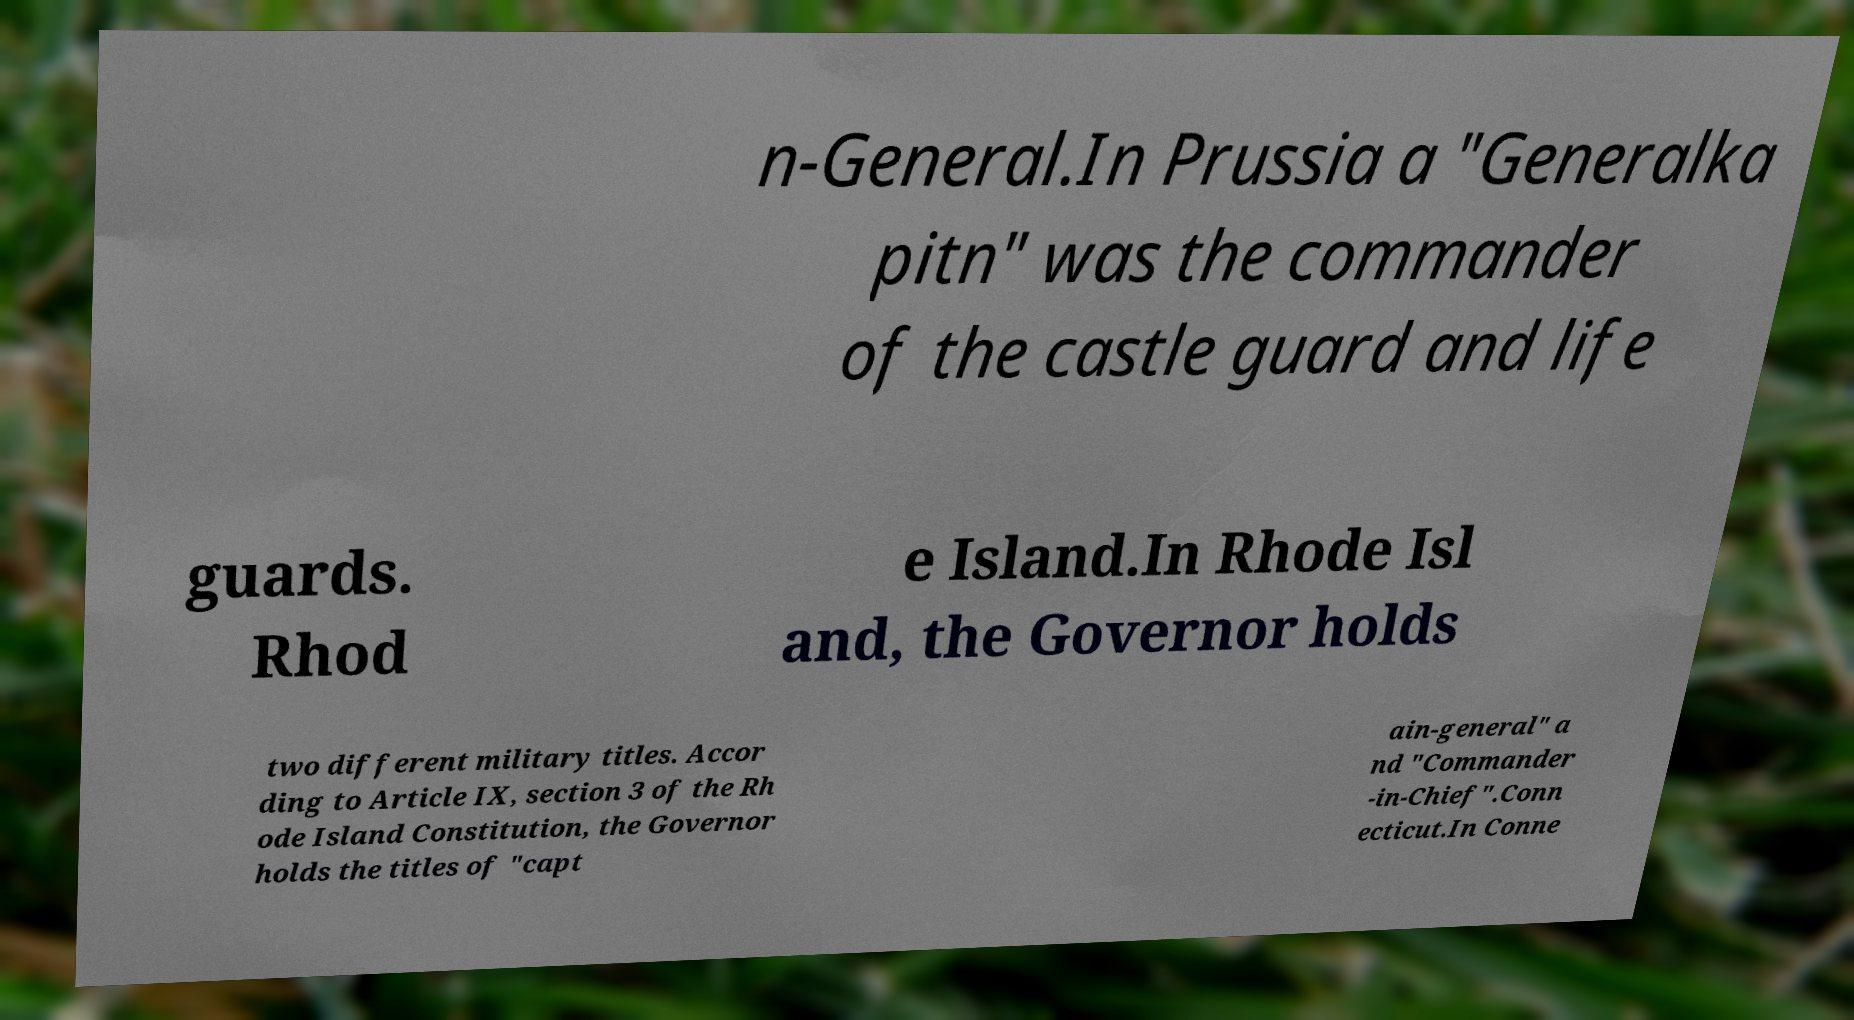I need the written content from this picture converted into text. Can you do that? n-General.In Prussia a "Generalka pitn" was the commander of the castle guard and life guards. Rhod e Island.In Rhode Isl and, the Governor holds two different military titles. Accor ding to Article IX, section 3 of the Rh ode Island Constitution, the Governor holds the titles of "capt ain-general" a nd "Commander -in-Chief".Conn ecticut.In Conne 